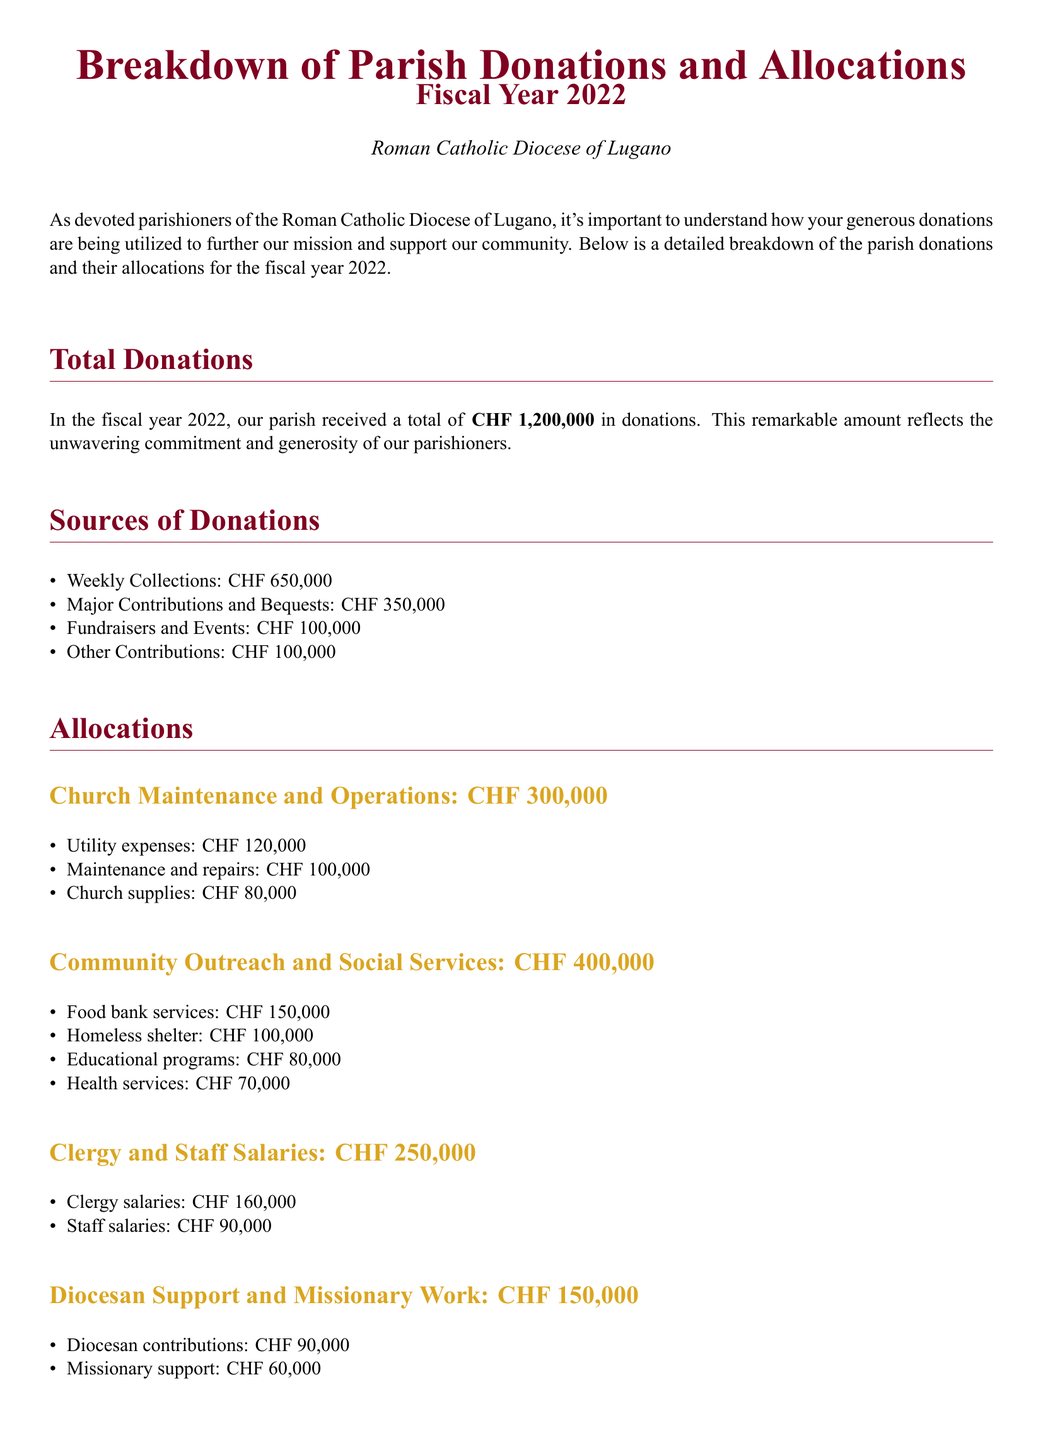what was the total amount of donations received in fiscal year 2022? The total amount of donations is stated in the document as CHF 1,200,000.
Answer: CHF 1,200,000 how much was contributed from weekly collections? Weekly collections are listed in the document as CHF 650,000.
Answer: CHF 650,000 what is the allocation for community outreach and social services? The allocation for community outreach and social services is provided in the document as CHF 400,000.
Answer: CHF 400,000 how much is set aside for the reserve fund? The reserve fund amount mentioned in the document is CHF 100,000.
Answer: CHF 100,000 how much does the parish allocate for clergy and staff salaries? The document states the allocation for clergy and staff salaries is CHF 250,000.
Answer: CHF 250,000 what is the total amount allocated to church maintenance and operations? The total allocation for church maintenance and operations according to the document is CHF 300,000.
Answer: CHF 300,000 how much support does the parish provide for the homeless shelter? The document indicates support for the homeless shelter is CHF 100,000.
Answer: CHF 100,000 what portion of the donations goes to diocesan support and missionary work? The document outlines that CHF 150,000 is allocated for diocesan support and missionary work.
Answer: CHF 150,000 what percentage shares the weekly collections contribute to the total donations? The percentage is derived from the relationship between CHF 650,000 and the total donations of CHF 1,200,000, which is approximately 54.17%.
Answer: 54.17% 